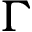<formula> <loc_0><loc_0><loc_500><loc_500>\Gamma</formula> 